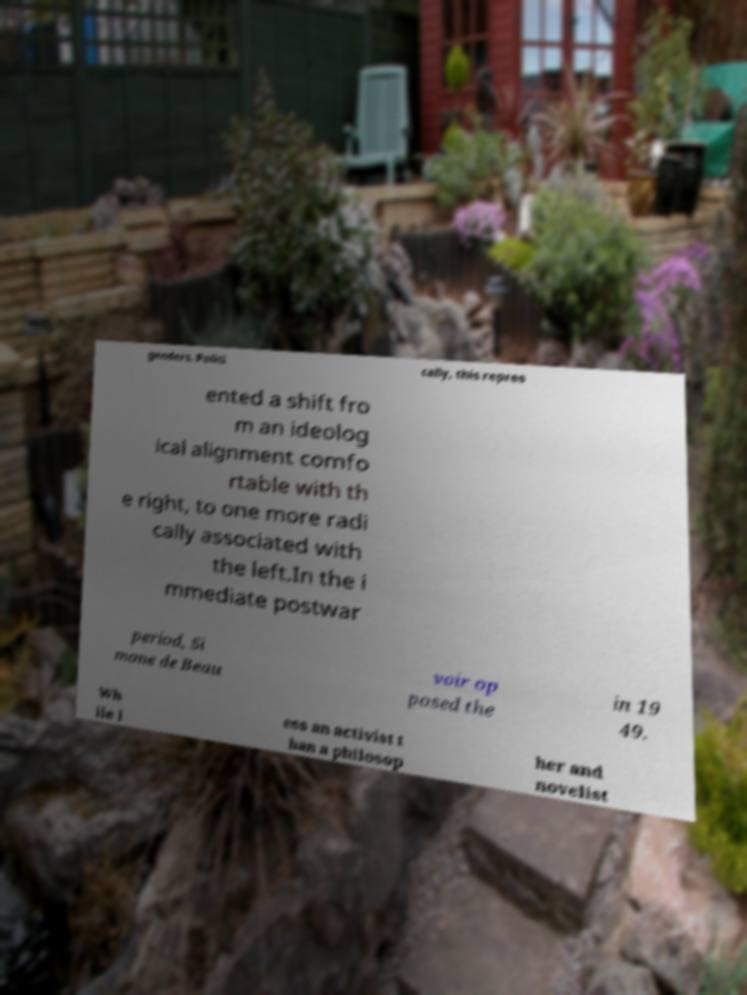Please read and relay the text visible in this image. What does it say? genders. Politi cally, this repres ented a shift fro m an ideolog ical alignment comfo rtable with th e right, to one more radi cally associated with the left.In the i mmediate postwar period, Si mone de Beau voir op posed the in 19 49. Wh ile l ess an activist t han a philosop her and novelist 